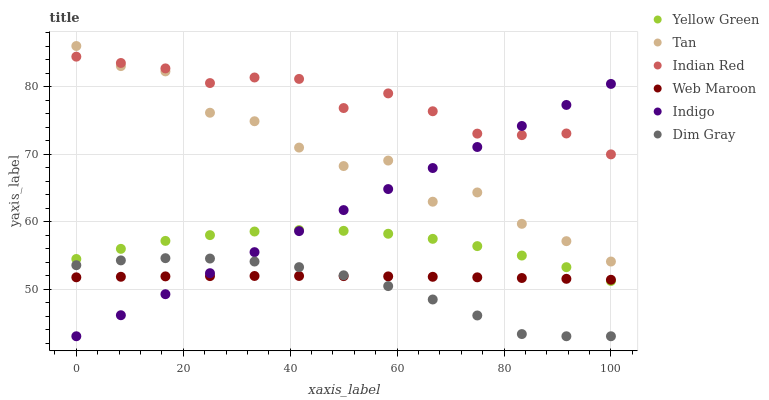Does Dim Gray have the minimum area under the curve?
Answer yes or no. Yes. Does Indian Red have the maximum area under the curve?
Answer yes or no. Yes. Does Indigo have the minimum area under the curve?
Answer yes or no. No. Does Indigo have the maximum area under the curve?
Answer yes or no. No. Is Indigo the smoothest?
Answer yes or no. Yes. Is Tan the roughest?
Answer yes or no. Yes. Is Yellow Green the smoothest?
Answer yes or no. No. Is Yellow Green the roughest?
Answer yes or no. No. Does Dim Gray have the lowest value?
Answer yes or no. Yes. Does Yellow Green have the lowest value?
Answer yes or no. No. Does Tan have the highest value?
Answer yes or no. Yes. Does Indigo have the highest value?
Answer yes or no. No. Is Dim Gray less than Yellow Green?
Answer yes or no. Yes. Is Tan greater than Dim Gray?
Answer yes or no. Yes. Does Web Maroon intersect Indigo?
Answer yes or no. Yes. Is Web Maroon less than Indigo?
Answer yes or no. No. Is Web Maroon greater than Indigo?
Answer yes or no. No. Does Dim Gray intersect Yellow Green?
Answer yes or no. No. 